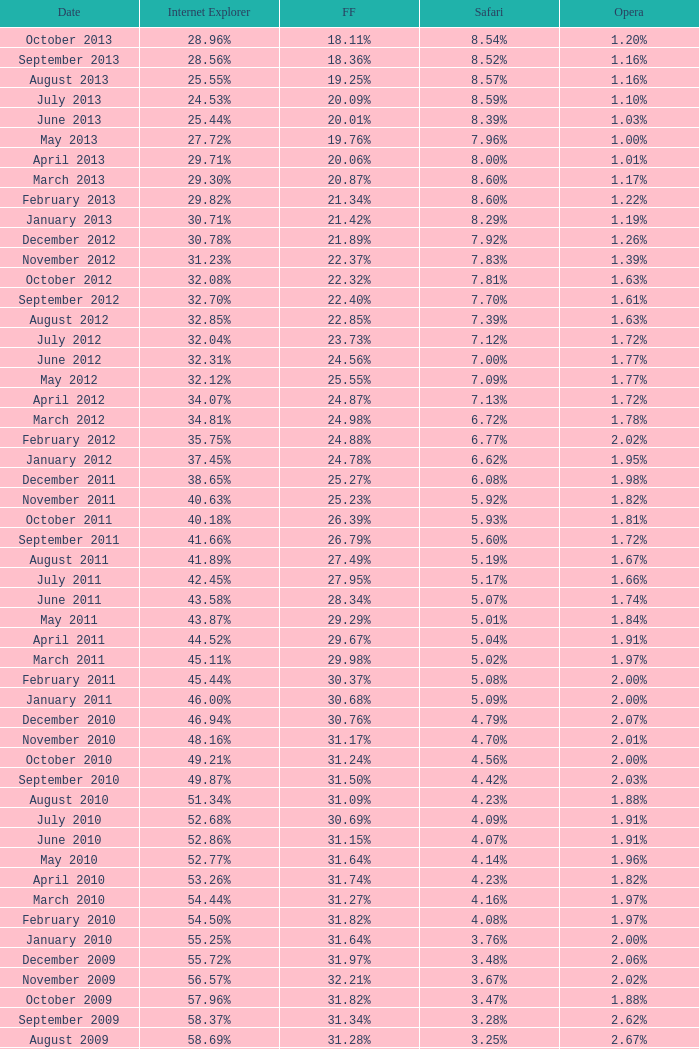What percentage of browsers were using Safari during the period in which 31.27% were using Firefox? 4.16%. 